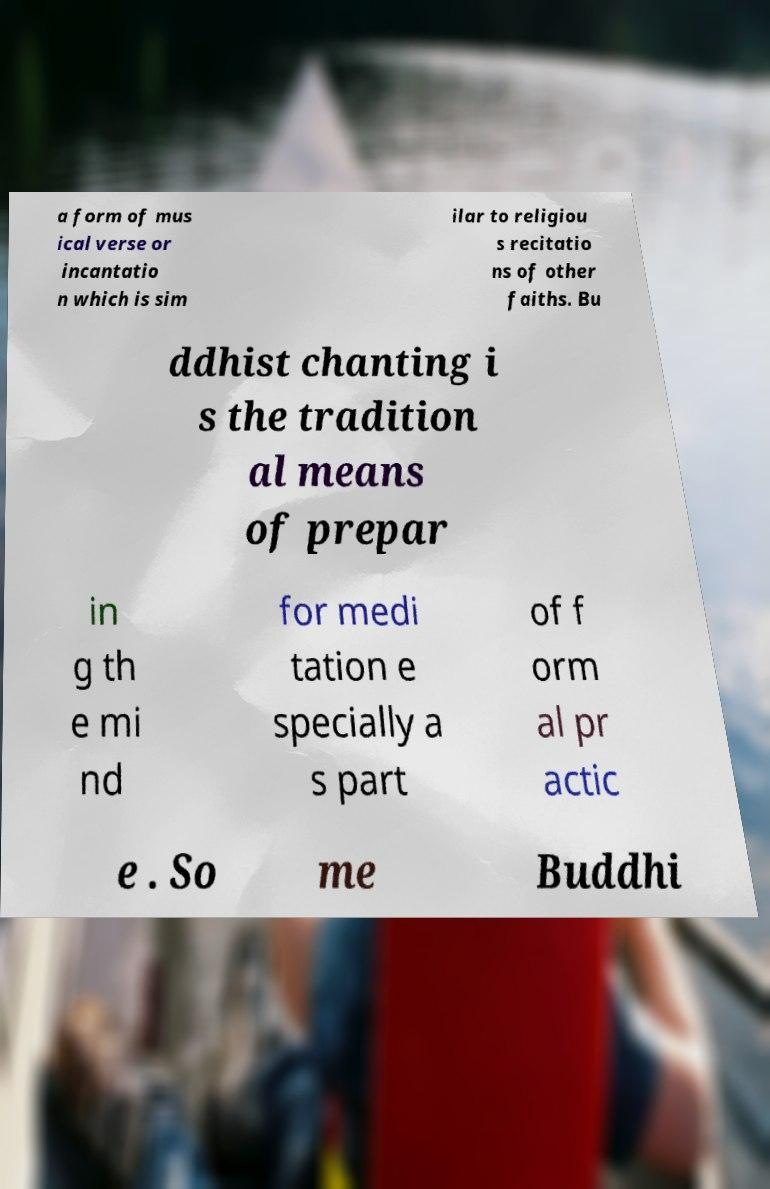Please identify and transcribe the text found in this image. a form of mus ical verse or incantatio n which is sim ilar to religiou s recitatio ns of other faiths. Bu ddhist chanting i s the tradition al means of prepar in g th e mi nd for medi tation e specially a s part of f orm al pr actic e . So me Buddhi 